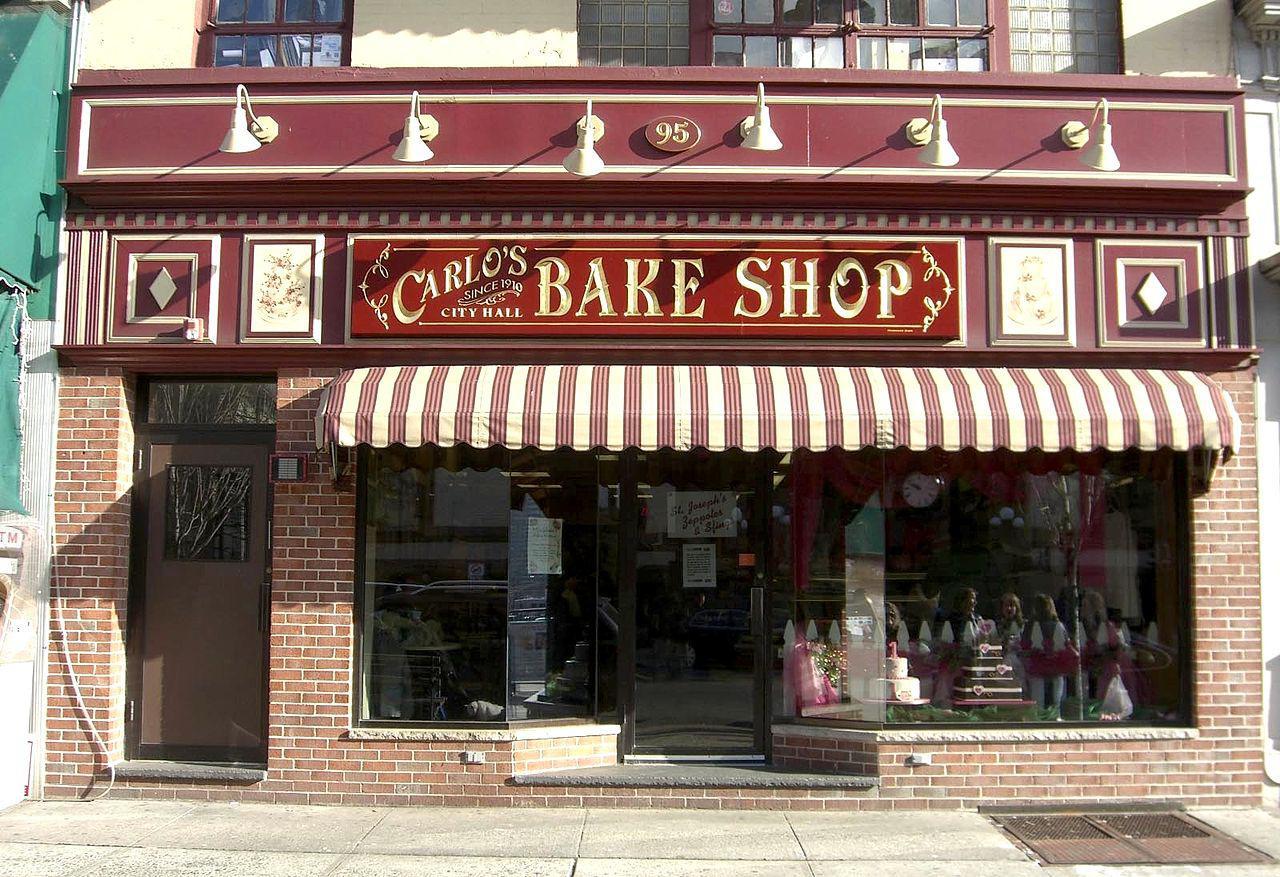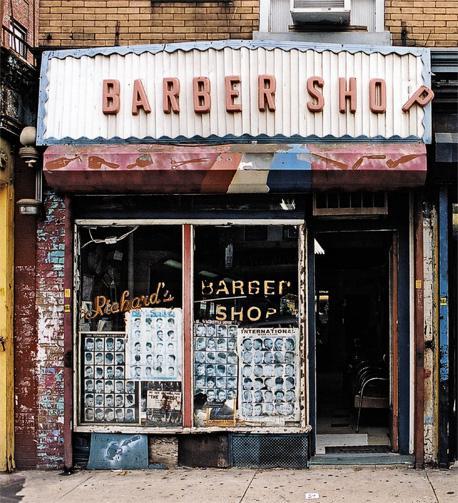The first image is the image on the left, the second image is the image on the right. Analyze the images presented: Is the assertion "There is a striped awning in the image on the left." valid? Answer yes or no. Yes. 